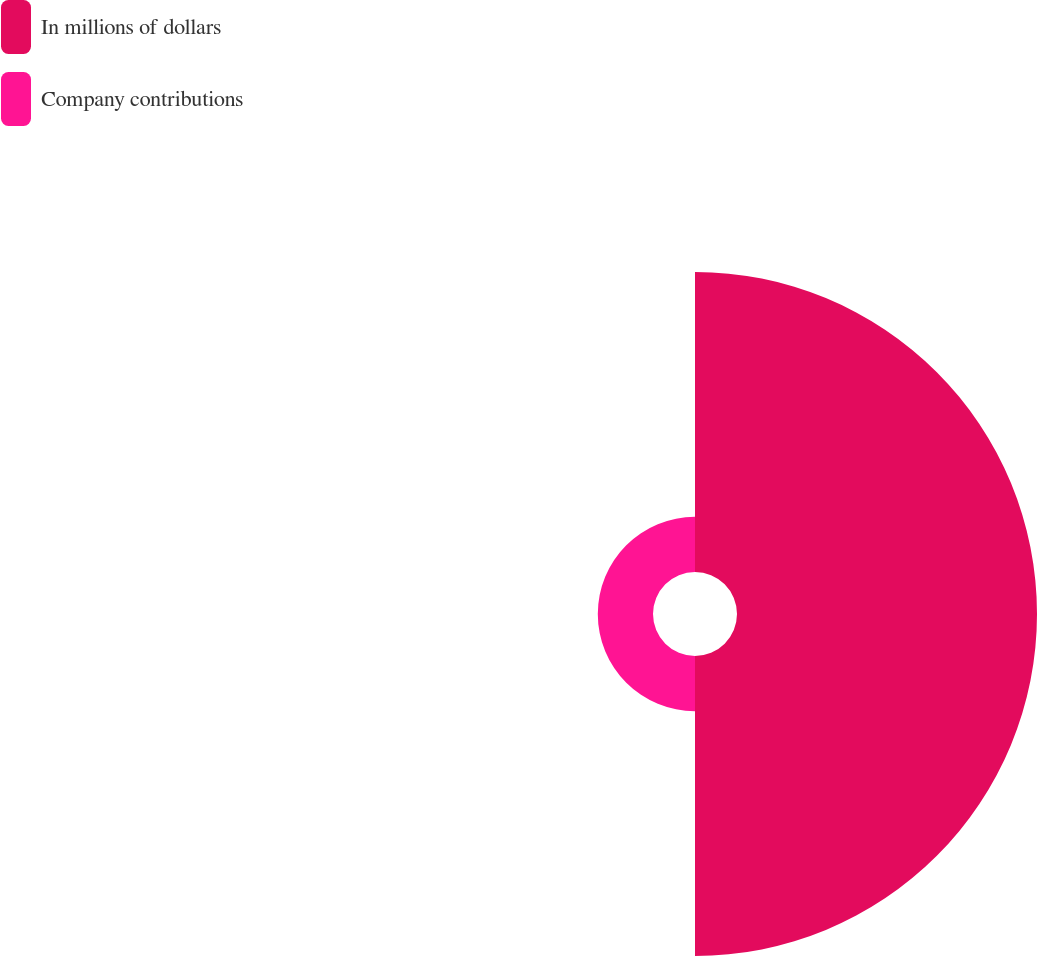Convert chart. <chart><loc_0><loc_0><loc_500><loc_500><pie_chart><fcel>In millions of dollars<fcel>Company contributions<nl><fcel>84.46%<fcel>15.54%<nl></chart> 